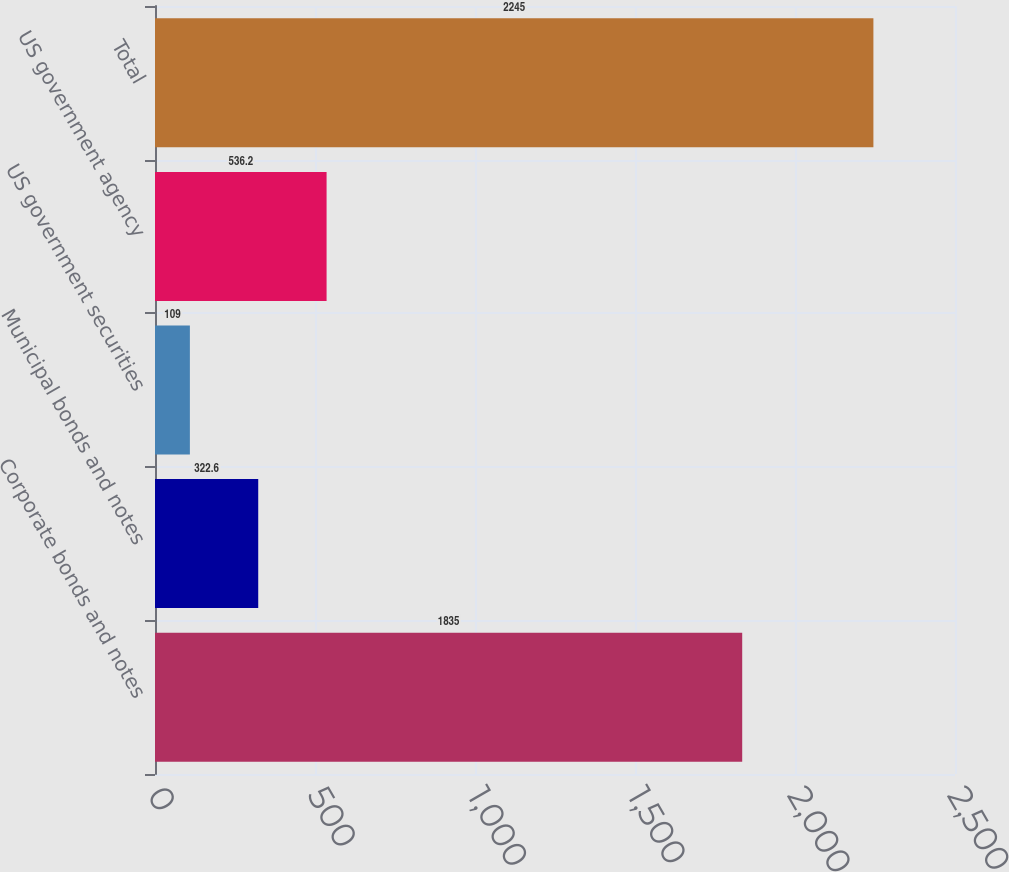Convert chart. <chart><loc_0><loc_0><loc_500><loc_500><bar_chart><fcel>Corporate bonds and notes<fcel>Municipal bonds and notes<fcel>US government securities<fcel>US government agency<fcel>Total<nl><fcel>1835<fcel>322.6<fcel>109<fcel>536.2<fcel>2245<nl></chart> 